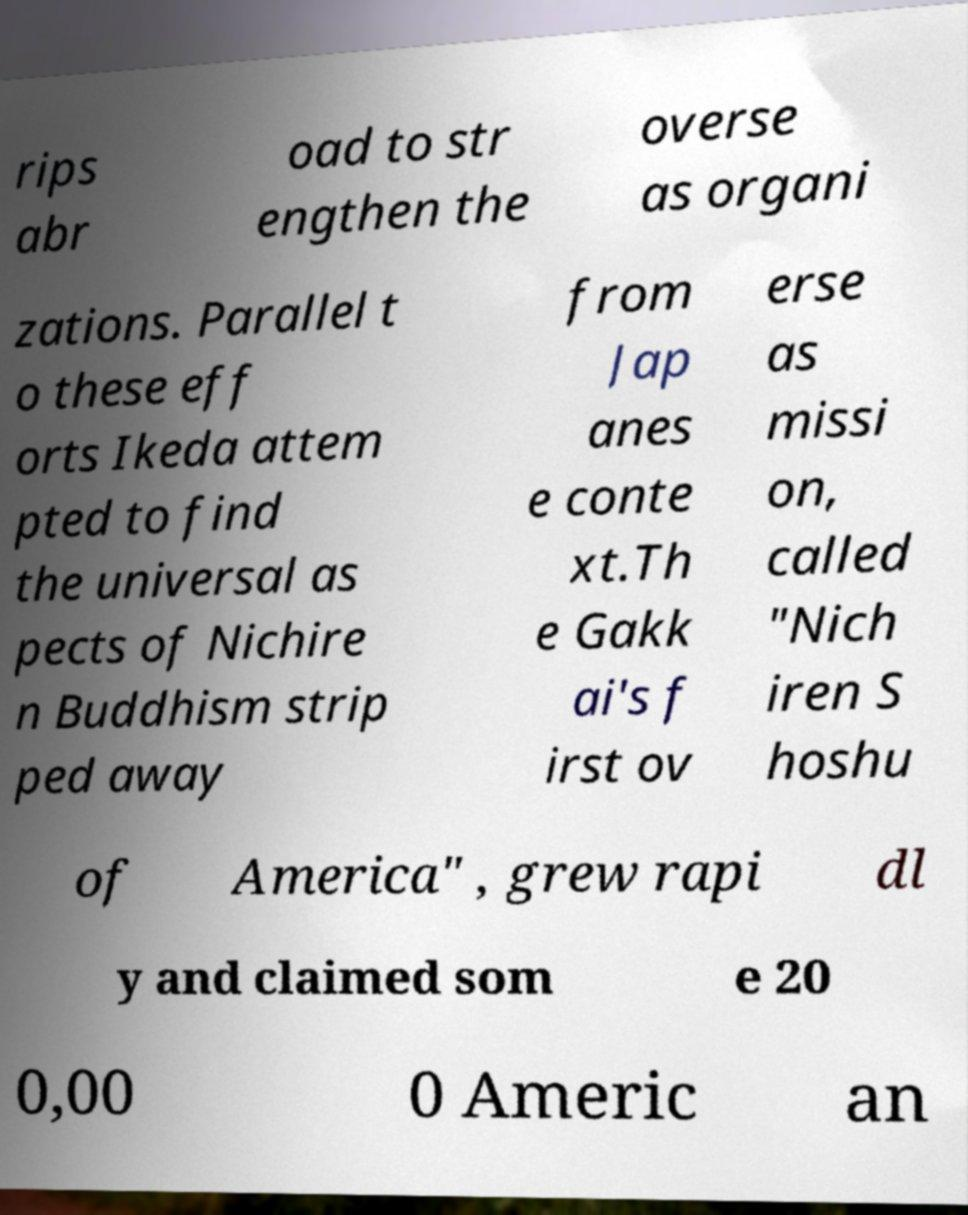Could you extract and type out the text from this image? rips abr oad to str engthen the overse as organi zations. Parallel t o these eff orts Ikeda attem pted to find the universal as pects of Nichire n Buddhism strip ped away from Jap anes e conte xt.Th e Gakk ai's f irst ov erse as missi on, called "Nich iren S hoshu of America" , grew rapi dl y and claimed som e 20 0,00 0 Americ an 